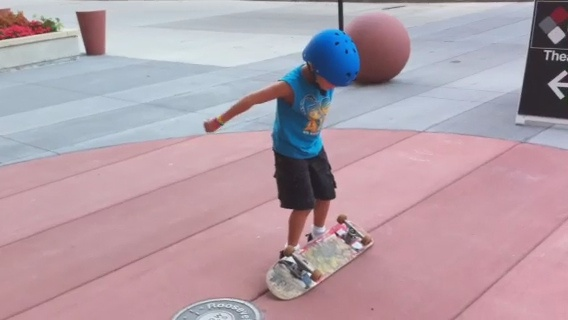Describe the objects in this image and their specific colors. I can see people in lightgray, black, blue, and navy tones, skateboard in lightgray, darkgray, gray, and pink tones, and potted plant in lightgray, brown, maroon, and darkgray tones in this image. 